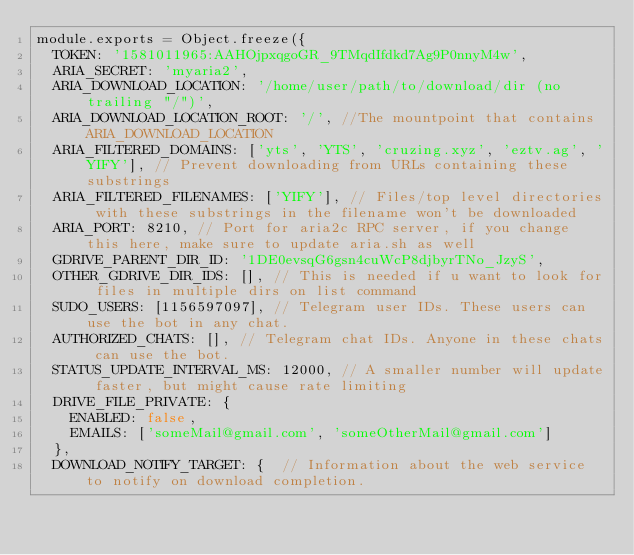<code> <loc_0><loc_0><loc_500><loc_500><_JavaScript_>module.exports = Object.freeze({
  TOKEN: '1581011965:AAHOjpxqgoGR_9TMqdIfdkd7Ag9P0nnyM4w',
  ARIA_SECRET: 'myaria2',
  ARIA_DOWNLOAD_LOCATION: '/home/user/path/to/download/dir (no trailing "/")',
  ARIA_DOWNLOAD_LOCATION_ROOT: '/', //The mountpoint that contains ARIA_DOWNLOAD_LOCATION
  ARIA_FILTERED_DOMAINS: ['yts', 'YTS', 'cruzing.xyz', 'eztv.ag', 'YIFY'], // Prevent downloading from URLs containing these substrings
  ARIA_FILTERED_FILENAMES: ['YIFY'], // Files/top level directories with these substrings in the filename won't be downloaded
  ARIA_PORT: 8210, // Port for aria2c RPC server, if you change this here, make sure to update aria.sh as well
  GDRIVE_PARENT_DIR_ID: '1DE0evsqG6gsn4cuWcP8djbyrTNo_JzyS',
  OTHER_GDRIVE_DIR_IDS: [], // This is needed if u want to look for files in multiple dirs on list command
  SUDO_USERS: [1156597097],	// Telegram user IDs. These users can use the bot in any chat.
  AUTHORIZED_CHATS: [],	// Telegram chat IDs. Anyone in these chats can use the bot.
  STATUS_UPDATE_INTERVAL_MS: 12000, // A smaller number will update faster, but might cause rate limiting
  DRIVE_FILE_PRIVATE: {
    ENABLED: false,
    EMAILS: ['someMail@gmail.com', 'someOtherMail@gmail.com']
  },
  DOWNLOAD_NOTIFY_TARGET: {  // Information about the web service to notify on download completion.</code> 